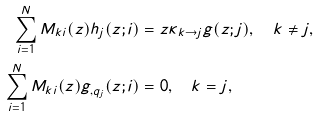<formula> <loc_0><loc_0><loc_500><loc_500>\sum _ { i = 1 } ^ { N } M _ { k i } ( z ) h _ { j } ( z ; i ) & = z \kappa _ { k \rightarrow j } g ( z ; j ) , \quad k \neq j , \\ \sum _ { i = 1 } ^ { N } M _ { k i } ( z ) g _ { , q _ { j } } ( z ; i ) & = 0 , \quad k = j ,</formula> 